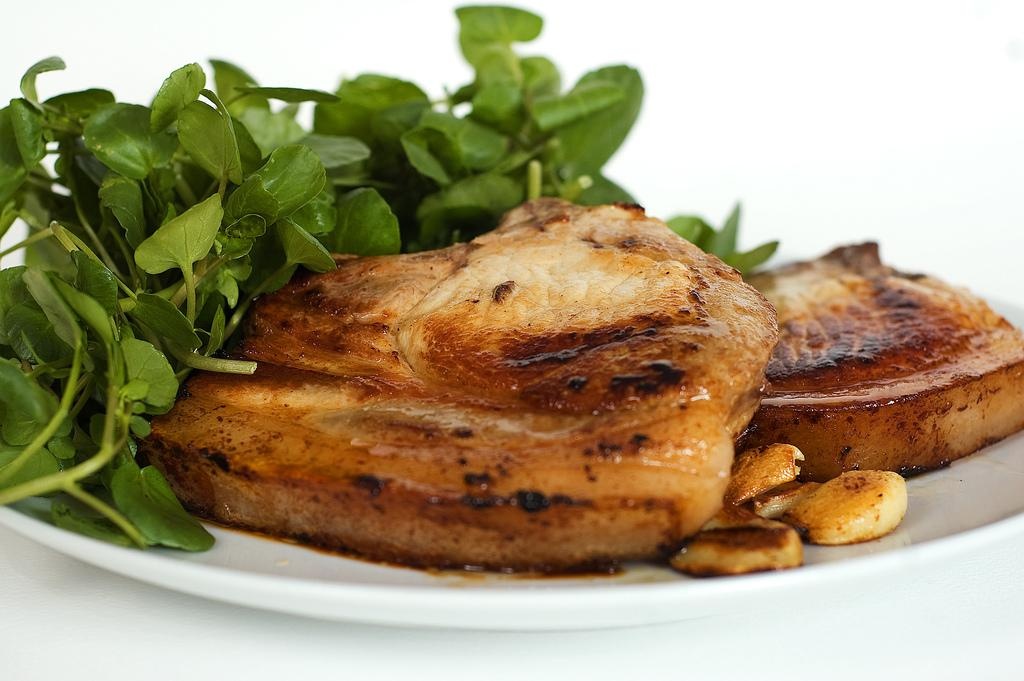What is on the plate that is visible in the image? The plate contains roasted bread pieces. What else can be seen in the image besides the plate? There are green leaves on the left side of the image. What type of mass is being held in the image? There is no mass or gathering of people present in the image. 